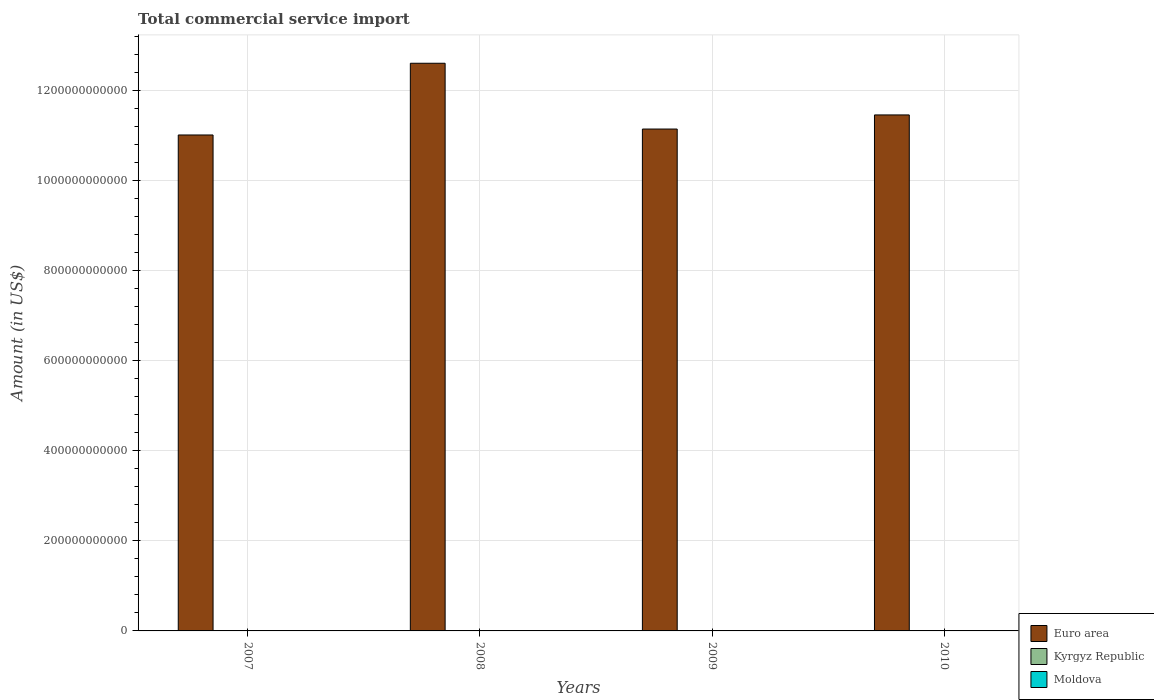Are the number of bars on each tick of the X-axis equal?
Offer a very short reply. Yes. How many bars are there on the 2nd tick from the left?
Your answer should be very brief. 3. What is the label of the 4th group of bars from the left?
Offer a very short reply. 2010. In how many cases, is the number of bars for a given year not equal to the number of legend labels?
Offer a terse response. 0. What is the total commercial service import in Euro area in 2007?
Your answer should be very brief. 1.10e+12. Across all years, what is the maximum total commercial service import in Euro area?
Make the answer very short. 1.26e+12. Across all years, what is the minimum total commercial service import in Moldova?
Provide a succinct answer. 6.19e+08. What is the total total commercial service import in Moldova in the graph?
Keep it short and to the point. 2.77e+09. What is the difference between the total commercial service import in Euro area in 2007 and that in 2009?
Give a very brief answer. -1.32e+1. What is the difference between the total commercial service import in Kyrgyz Republic in 2007 and the total commercial service import in Moldova in 2010?
Your answer should be compact. -7.84e+07. What is the average total commercial service import in Kyrgyz Republic per year?
Make the answer very short. 7.58e+08. In the year 2008, what is the difference between the total commercial service import in Kyrgyz Republic and total commercial service import in Euro area?
Offer a very short reply. -1.26e+12. What is the ratio of the total commercial service import in Moldova in 2009 to that in 2010?
Ensure brevity in your answer.  1.01. Is the difference between the total commercial service import in Kyrgyz Republic in 2007 and 2009 greater than the difference between the total commercial service import in Euro area in 2007 and 2009?
Provide a short and direct response. Yes. What is the difference between the highest and the second highest total commercial service import in Kyrgyz Republic?
Your answer should be compact. 1.12e+08. What is the difference between the highest and the lowest total commercial service import in Euro area?
Make the answer very short. 1.59e+11. In how many years, is the total commercial service import in Kyrgyz Republic greater than the average total commercial service import in Kyrgyz Republic taken over all years?
Your answer should be very brief. 2. What does the 1st bar from the left in 2007 represents?
Provide a short and direct response. Euro area. What does the 2nd bar from the right in 2008 represents?
Your answer should be very brief. Kyrgyz Republic. Are all the bars in the graph horizontal?
Provide a succinct answer. No. How many years are there in the graph?
Provide a short and direct response. 4. What is the difference between two consecutive major ticks on the Y-axis?
Give a very brief answer. 2.00e+11. How are the legend labels stacked?
Offer a very short reply. Vertical. What is the title of the graph?
Make the answer very short. Total commercial service import. Does "Greece" appear as one of the legend labels in the graph?
Offer a terse response. No. What is the label or title of the Y-axis?
Your response must be concise. Amount (in US$). What is the Amount (in US$) in Euro area in 2007?
Offer a terse response. 1.10e+12. What is the Amount (in US$) in Kyrgyz Republic in 2007?
Give a very brief answer. 5.99e+08. What is the Amount (in US$) of Moldova in 2007?
Ensure brevity in your answer.  6.19e+08. What is the Amount (in US$) of Euro area in 2008?
Provide a succinct answer. 1.26e+12. What is the Amount (in US$) of Kyrgyz Republic in 2008?
Provide a succinct answer. 9.04e+08. What is the Amount (in US$) of Moldova in 2008?
Give a very brief answer. 7.94e+08. What is the Amount (in US$) in Euro area in 2009?
Your answer should be compact. 1.11e+12. What is the Amount (in US$) of Kyrgyz Republic in 2009?
Make the answer very short. 7.37e+08. What is the Amount (in US$) in Moldova in 2009?
Offer a very short reply. 6.82e+08. What is the Amount (in US$) of Euro area in 2010?
Make the answer very short. 1.15e+12. What is the Amount (in US$) of Kyrgyz Republic in 2010?
Your answer should be compact. 7.92e+08. What is the Amount (in US$) in Moldova in 2010?
Make the answer very short. 6.78e+08. Across all years, what is the maximum Amount (in US$) in Euro area?
Make the answer very short. 1.26e+12. Across all years, what is the maximum Amount (in US$) of Kyrgyz Republic?
Offer a terse response. 9.04e+08. Across all years, what is the maximum Amount (in US$) in Moldova?
Provide a succinct answer. 7.94e+08. Across all years, what is the minimum Amount (in US$) in Euro area?
Give a very brief answer. 1.10e+12. Across all years, what is the minimum Amount (in US$) of Kyrgyz Republic?
Give a very brief answer. 5.99e+08. Across all years, what is the minimum Amount (in US$) of Moldova?
Keep it short and to the point. 6.19e+08. What is the total Amount (in US$) in Euro area in the graph?
Your answer should be very brief. 4.62e+12. What is the total Amount (in US$) of Kyrgyz Republic in the graph?
Your answer should be compact. 3.03e+09. What is the total Amount (in US$) in Moldova in the graph?
Your answer should be compact. 2.77e+09. What is the difference between the Amount (in US$) of Euro area in 2007 and that in 2008?
Your answer should be compact. -1.59e+11. What is the difference between the Amount (in US$) of Kyrgyz Republic in 2007 and that in 2008?
Give a very brief answer. -3.05e+08. What is the difference between the Amount (in US$) in Moldova in 2007 and that in 2008?
Keep it short and to the point. -1.75e+08. What is the difference between the Amount (in US$) in Euro area in 2007 and that in 2009?
Keep it short and to the point. -1.32e+1. What is the difference between the Amount (in US$) in Kyrgyz Republic in 2007 and that in 2009?
Give a very brief answer. -1.38e+08. What is the difference between the Amount (in US$) in Moldova in 2007 and that in 2009?
Give a very brief answer. -6.35e+07. What is the difference between the Amount (in US$) of Euro area in 2007 and that in 2010?
Your answer should be compact. -4.45e+1. What is the difference between the Amount (in US$) in Kyrgyz Republic in 2007 and that in 2010?
Provide a succinct answer. -1.93e+08. What is the difference between the Amount (in US$) of Moldova in 2007 and that in 2010?
Offer a terse response. -5.89e+07. What is the difference between the Amount (in US$) of Euro area in 2008 and that in 2009?
Provide a short and direct response. 1.46e+11. What is the difference between the Amount (in US$) of Kyrgyz Republic in 2008 and that in 2009?
Offer a terse response. 1.67e+08. What is the difference between the Amount (in US$) in Moldova in 2008 and that in 2009?
Provide a succinct answer. 1.11e+08. What is the difference between the Amount (in US$) of Euro area in 2008 and that in 2010?
Provide a succinct answer. 1.15e+11. What is the difference between the Amount (in US$) of Kyrgyz Republic in 2008 and that in 2010?
Your answer should be compact. 1.12e+08. What is the difference between the Amount (in US$) of Moldova in 2008 and that in 2010?
Give a very brief answer. 1.16e+08. What is the difference between the Amount (in US$) in Euro area in 2009 and that in 2010?
Your answer should be compact. -3.13e+1. What is the difference between the Amount (in US$) of Kyrgyz Republic in 2009 and that in 2010?
Keep it short and to the point. -5.50e+07. What is the difference between the Amount (in US$) of Moldova in 2009 and that in 2010?
Give a very brief answer. 4.61e+06. What is the difference between the Amount (in US$) of Euro area in 2007 and the Amount (in US$) of Kyrgyz Republic in 2008?
Provide a short and direct response. 1.10e+12. What is the difference between the Amount (in US$) of Euro area in 2007 and the Amount (in US$) of Moldova in 2008?
Make the answer very short. 1.10e+12. What is the difference between the Amount (in US$) in Kyrgyz Republic in 2007 and the Amount (in US$) in Moldova in 2008?
Your answer should be very brief. -1.94e+08. What is the difference between the Amount (in US$) in Euro area in 2007 and the Amount (in US$) in Kyrgyz Republic in 2009?
Keep it short and to the point. 1.10e+12. What is the difference between the Amount (in US$) of Euro area in 2007 and the Amount (in US$) of Moldova in 2009?
Offer a terse response. 1.10e+12. What is the difference between the Amount (in US$) of Kyrgyz Republic in 2007 and the Amount (in US$) of Moldova in 2009?
Give a very brief answer. -8.30e+07. What is the difference between the Amount (in US$) in Euro area in 2007 and the Amount (in US$) in Kyrgyz Republic in 2010?
Offer a very short reply. 1.10e+12. What is the difference between the Amount (in US$) of Euro area in 2007 and the Amount (in US$) of Moldova in 2010?
Offer a very short reply. 1.10e+12. What is the difference between the Amount (in US$) in Kyrgyz Republic in 2007 and the Amount (in US$) in Moldova in 2010?
Offer a terse response. -7.84e+07. What is the difference between the Amount (in US$) in Euro area in 2008 and the Amount (in US$) in Kyrgyz Republic in 2009?
Provide a succinct answer. 1.26e+12. What is the difference between the Amount (in US$) in Euro area in 2008 and the Amount (in US$) in Moldova in 2009?
Provide a short and direct response. 1.26e+12. What is the difference between the Amount (in US$) in Kyrgyz Republic in 2008 and the Amount (in US$) in Moldova in 2009?
Make the answer very short. 2.22e+08. What is the difference between the Amount (in US$) of Euro area in 2008 and the Amount (in US$) of Kyrgyz Republic in 2010?
Your response must be concise. 1.26e+12. What is the difference between the Amount (in US$) in Euro area in 2008 and the Amount (in US$) in Moldova in 2010?
Provide a short and direct response. 1.26e+12. What is the difference between the Amount (in US$) in Kyrgyz Republic in 2008 and the Amount (in US$) in Moldova in 2010?
Offer a very short reply. 2.27e+08. What is the difference between the Amount (in US$) in Euro area in 2009 and the Amount (in US$) in Kyrgyz Republic in 2010?
Offer a terse response. 1.11e+12. What is the difference between the Amount (in US$) in Euro area in 2009 and the Amount (in US$) in Moldova in 2010?
Provide a succinct answer. 1.11e+12. What is the difference between the Amount (in US$) of Kyrgyz Republic in 2009 and the Amount (in US$) of Moldova in 2010?
Give a very brief answer. 5.95e+07. What is the average Amount (in US$) of Euro area per year?
Give a very brief answer. 1.16e+12. What is the average Amount (in US$) of Kyrgyz Republic per year?
Offer a terse response. 7.58e+08. What is the average Amount (in US$) in Moldova per year?
Keep it short and to the point. 6.93e+08. In the year 2007, what is the difference between the Amount (in US$) of Euro area and Amount (in US$) of Kyrgyz Republic?
Your answer should be very brief. 1.10e+12. In the year 2007, what is the difference between the Amount (in US$) of Euro area and Amount (in US$) of Moldova?
Ensure brevity in your answer.  1.10e+12. In the year 2007, what is the difference between the Amount (in US$) of Kyrgyz Republic and Amount (in US$) of Moldova?
Offer a terse response. -1.96e+07. In the year 2008, what is the difference between the Amount (in US$) of Euro area and Amount (in US$) of Kyrgyz Republic?
Offer a very short reply. 1.26e+12. In the year 2008, what is the difference between the Amount (in US$) of Euro area and Amount (in US$) of Moldova?
Keep it short and to the point. 1.26e+12. In the year 2008, what is the difference between the Amount (in US$) of Kyrgyz Republic and Amount (in US$) of Moldova?
Make the answer very short. 1.11e+08. In the year 2009, what is the difference between the Amount (in US$) in Euro area and Amount (in US$) in Kyrgyz Republic?
Your answer should be compact. 1.11e+12. In the year 2009, what is the difference between the Amount (in US$) of Euro area and Amount (in US$) of Moldova?
Ensure brevity in your answer.  1.11e+12. In the year 2009, what is the difference between the Amount (in US$) of Kyrgyz Republic and Amount (in US$) of Moldova?
Provide a short and direct response. 5.49e+07. In the year 2010, what is the difference between the Amount (in US$) of Euro area and Amount (in US$) of Kyrgyz Republic?
Offer a terse response. 1.15e+12. In the year 2010, what is the difference between the Amount (in US$) of Euro area and Amount (in US$) of Moldova?
Offer a very short reply. 1.15e+12. In the year 2010, what is the difference between the Amount (in US$) of Kyrgyz Republic and Amount (in US$) of Moldova?
Provide a succinct answer. 1.15e+08. What is the ratio of the Amount (in US$) of Euro area in 2007 to that in 2008?
Provide a succinct answer. 0.87. What is the ratio of the Amount (in US$) in Kyrgyz Republic in 2007 to that in 2008?
Your answer should be compact. 0.66. What is the ratio of the Amount (in US$) in Moldova in 2007 to that in 2008?
Give a very brief answer. 0.78. What is the ratio of the Amount (in US$) in Euro area in 2007 to that in 2009?
Your answer should be very brief. 0.99. What is the ratio of the Amount (in US$) in Kyrgyz Republic in 2007 to that in 2009?
Ensure brevity in your answer.  0.81. What is the ratio of the Amount (in US$) of Moldova in 2007 to that in 2009?
Give a very brief answer. 0.91. What is the ratio of the Amount (in US$) in Euro area in 2007 to that in 2010?
Your response must be concise. 0.96. What is the ratio of the Amount (in US$) of Kyrgyz Republic in 2007 to that in 2010?
Offer a terse response. 0.76. What is the ratio of the Amount (in US$) in Moldova in 2007 to that in 2010?
Your answer should be compact. 0.91. What is the ratio of the Amount (in US$) of Euro area in 2008 to that in 2009?
Provide a succinct answer. 1.13. What is the ratio of the Amount (in US$) in Kyrgyz Republic in 2008 to that in 2009?
Offer a terse response. 1.23. What is the ratio of the Amount (in US$) of Moldova in 2008 to that in 2009?
Your answer should be compact. 1.16. What is the ratio of the Amount (in US$) in Euro area in 2008 to that in 2010?
Your answer should be compact. 1.1. What is the ratio of the Amount (in US$) of Kyrgyz Republic in 2008 to that in 2010?
Your response must be concise. 1.14. What is the ratio of the Amount (in US$) in Moldova in 2008 to that in 2010?
Offer a terse response. 1.17. What is the ratio of the Amount (in US$) of Euro area in 2009 to that in 2010?
Provide a short and direct response. 0.97. What is the ratio of the Amount (in US$) in Kyrgyz Republic in 2009 to that in 2010?
Ensure brevity in your answer.  0.93. What is the ratio of the Amount (in US$) in Moldova in 2009 to that in 2010?
Give a very brief answer. 1.01. What is the difference between the highest and the second highest Amount (in US$) in Euro area?
Provide a short and direct response. 1.15e+11. What is the difference between the highest and the second highest Amount (in US$) in Kyrgyz Republic?
Offer a very short reply. 1.12e+08. What is the difference between the highest and the second highest Amount (in US$) of Moldova?
Ensure brevity in your answer.  1.11e+08. What is the difference between the highest and the lowest Amount (in US$) in Euro area?
Provide a short and direct response. 1.59e+11. What is the difference between the highest and the lowest Amount (in US$) of Kyrgyz Republic?
Give a very brief answer. 3.05e+08. What is the difference between the highest and the lowest Amount (in US$) in Moldova?
Offer a terse response. 1.75e+08. 